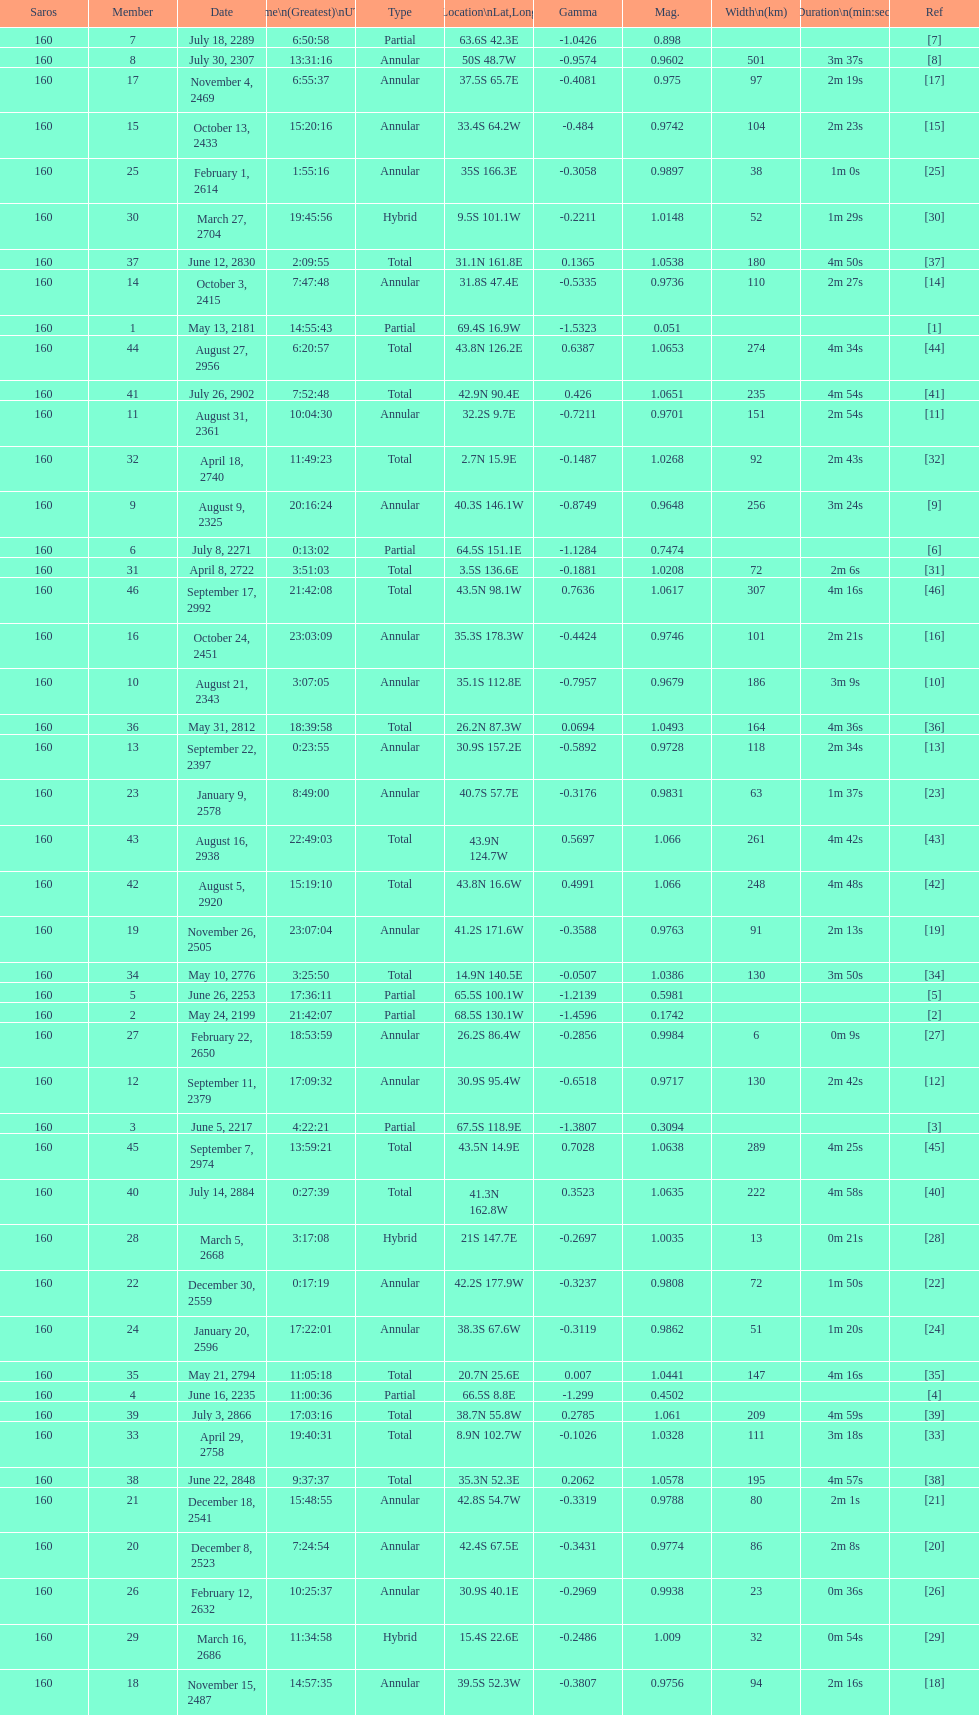How long did 18 last? 2m 16s. 